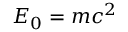Convert formula to latex. <formula><loc_0><loc_0><loc_500><loc_500>E _ { 0 } = m c ^ { 2 }</formula> 